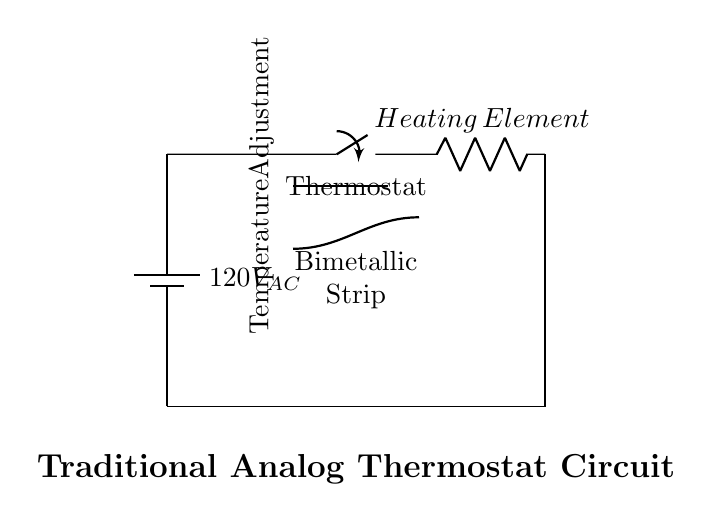What is the power supply voltage in the circuit? The power supply voltage is indicated next to the battery symbol, showing it is 120V AC. This value can be found at the starting point of the circuit diagram.
Answer: 120V AC What component controls the temperature in this circuit? The thermostat is the component responsible for controlling the temperature. It is represented by the switch labeled "Thermostat," which determines whether the heating element is activated based on the temperature setting.
Answer: Thermostat What element generates heat in this circuit? The heating element is the part of the circuit that generates heat. It is explicitly labeled as "Heating Element" and connected directly after the thermostat switch in the circuit layout.
Answer: Heating Element What is the purpose of the bimetallic strip in this circuit? The bimetallic strip serves to detect temperature changes and operates the thermostat switch. When the temperature changes, the strip bends, causing the switch to either open or close to maintain a consistent temperature.
Answer: Control temperature How is the temperature adjusted in the circuit? The temperature adjustment is indicated by a labeled line that shows it is connected to the thermostat, allowing users to set their desired temperature, which is then monitored by the bimetallic strip for maintaining the desired heating level.
Answer: Temperature Adjustment What type of current does this circuit use? The circuit uses alternating current (AC), as indicated by the "AC" designation next to the voltage of the power supply at the start of the diagram.
Answer: Alternating Current Where does the return path for current flow? The return path for current flows from the heating element down to the bottom of the circuit, returning to the battery. It is illustrated by the downward line leading to the horizontal line back to the power supply.
Answer: Bottom to top 